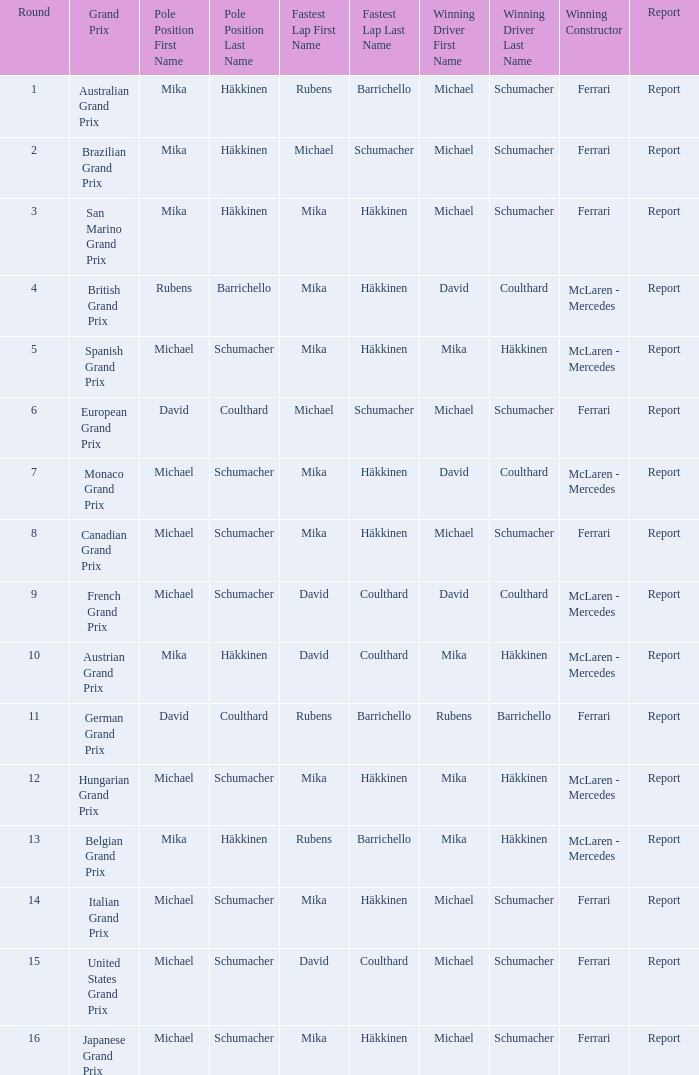How many drivers won the Italian Grand Prix? 1.0. Would you be able to parse every entry in this table? {'header': ['Round', 'Grand Prix', 'Pole Position First Name', 'Pole Position Last Name', 'Fastest Lap First Name', 'Fastest Lap Last Name', 'Winning Driver First Name', 'Winning Driver Last Name', 'Winning Constructor', 'Report'], 'rows': [['1', 'Australian Grand Prix', 'Mika', 'Häkkinen', 'Rubens', 'Barrichello', 'Michael', 'Schumacher', 'Ferrari', 'Report'], ['2', 'Brazilian Grand Prix', 'Mika', 'Häkkinen', 'Michael', 'Schumacher', 'Michael', 'Schumacher', 'Ferrari', 'Report'], ['3', 'San Marino Grand Prix', 'Mika', 'Häkkinen', 'Mika', 'Häkkinen', 'Michael', 'Schumacher', 'Ferrari', 'Report'], ['4', 'British Grand Prix', 'Rubens', 'Barrichello', 'Mika', 'Häkkinen', 'David', 'Coulthard', 'McLaren - Mercedes', 'Report'], ['5', 'Spanish Grand Prix', 'Michael', 'Schumacher', 'Mika', 'Häkkinen', 'Mika', 'Häkkinen', 'McLaren - Mercedes', 'Report'], ['6', 'European Grand Prix', 'David', 'Coulthard', 'Michael', 'Schumacher', 'Michael', 'Schumacher', 'Ferrari', 'Report'], ['7', 'Monaco Grand Prix', 'Michael', 'Schumacher', 'Mika', 'Häkkinen', 'David', 'Coulthard', 'McLaren - Mercedes', 'Report'], ['8', 'Canadian Grand Prix', 'Michael', 'Schumacher', 'Mika', 'Häkkinen', 'Michael', 'Schumacher', 'Ferrari', 'Report'], ['9', 'French Grand Prix', 'Michael', 'Schumacher', 'David', 'Coulthard', 'David', 'Coulthard', 'McLaren - Mercedes', 'Report'], ['10', 'Austrian Grand Prix', 'Mika', 'Häkkinen', 'David', 'Coulthard', 'Mika', 'Häkkinen', 'McLaren - Mercedes', 'Report'], ['11', 'German Grand Prix', 'David', 'Coulthard', 'Rubens', 'Barrichello', 'Rubens', 'Barrichello', 'Ferrari', 'Report'], ['12', 'Hungarian Grand Prix', 'Michael', 'Schumacher', 'Mika', 'Häkkinen', 'Mika', 'Häkkinen', 'McLaren - Mercedes', 'Report'], ['13', 'Belgian Grand Prix', 'Mika', 'Häkkinen', 'Rubens', 'Barrichello', 'Mika', 'Häkkinen', 'McLaren - Mercedes', 'Report'], ['14', 'Italian Grand Prix', 'Michael', 'Schumacher', 'Mika', 'Häkkinen', 'Michael', 'Schumacher', 'Ferrari', 'Report'], ['15', 'United States Grand Prix', 'Michael', 'Schumacher', 'David', 'Coulthard', 'Michael', 'Schumacher', 'Ferrari', 'Report'], ['16', 'Japanese Grand Prix', 'Michael', 'Schumacher', 'Mika', 'Häkkinen', 'Michael', 'Schumacher', 'Ferrari', 'Report']]} 